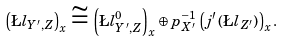Convert formula to latex. <formula><loc_0><loc_0><loc_500><loc_500>\left ( \L l _ { Y ^ { \prime } , Z } \right ) _ { x } \cong \left ( \L l _ { Y ^ { \prime } , Z } ^ { 0 } \right ) _ { x } \oplus p _ { X ^ { \prime } } ^ { - 1 } \left ( j ^ { \prime } \left ( \L l _ { Z ^ { \prime } } \right ) \right ) _ { x } .</formula> 